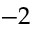Convert formula to latex. <formula><loc_0><loc_0><loc_500><loc_500>- 2</formula> 